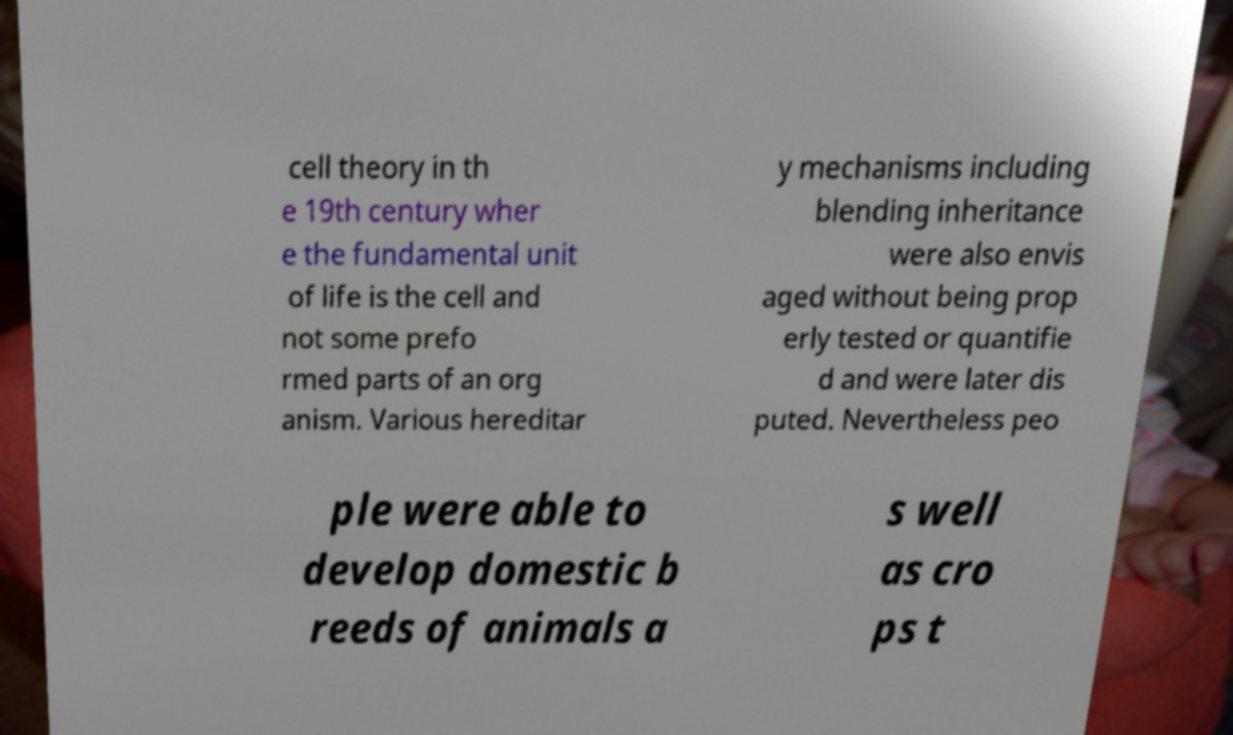Could you assist in decoding the text presented in this image and type it out clearly? cell theory in th e 19th century wher e the fundamental unit of life is the cell and not some prefo rmed parts of an org anism. Various hereditar y mechanisms including blending inheritance were also envis aged without being prop erly tested or quantifie d and were later dis puted. Nevertheless peo ple were able to develop domestic b reeds of animals a s well as cro ps t 